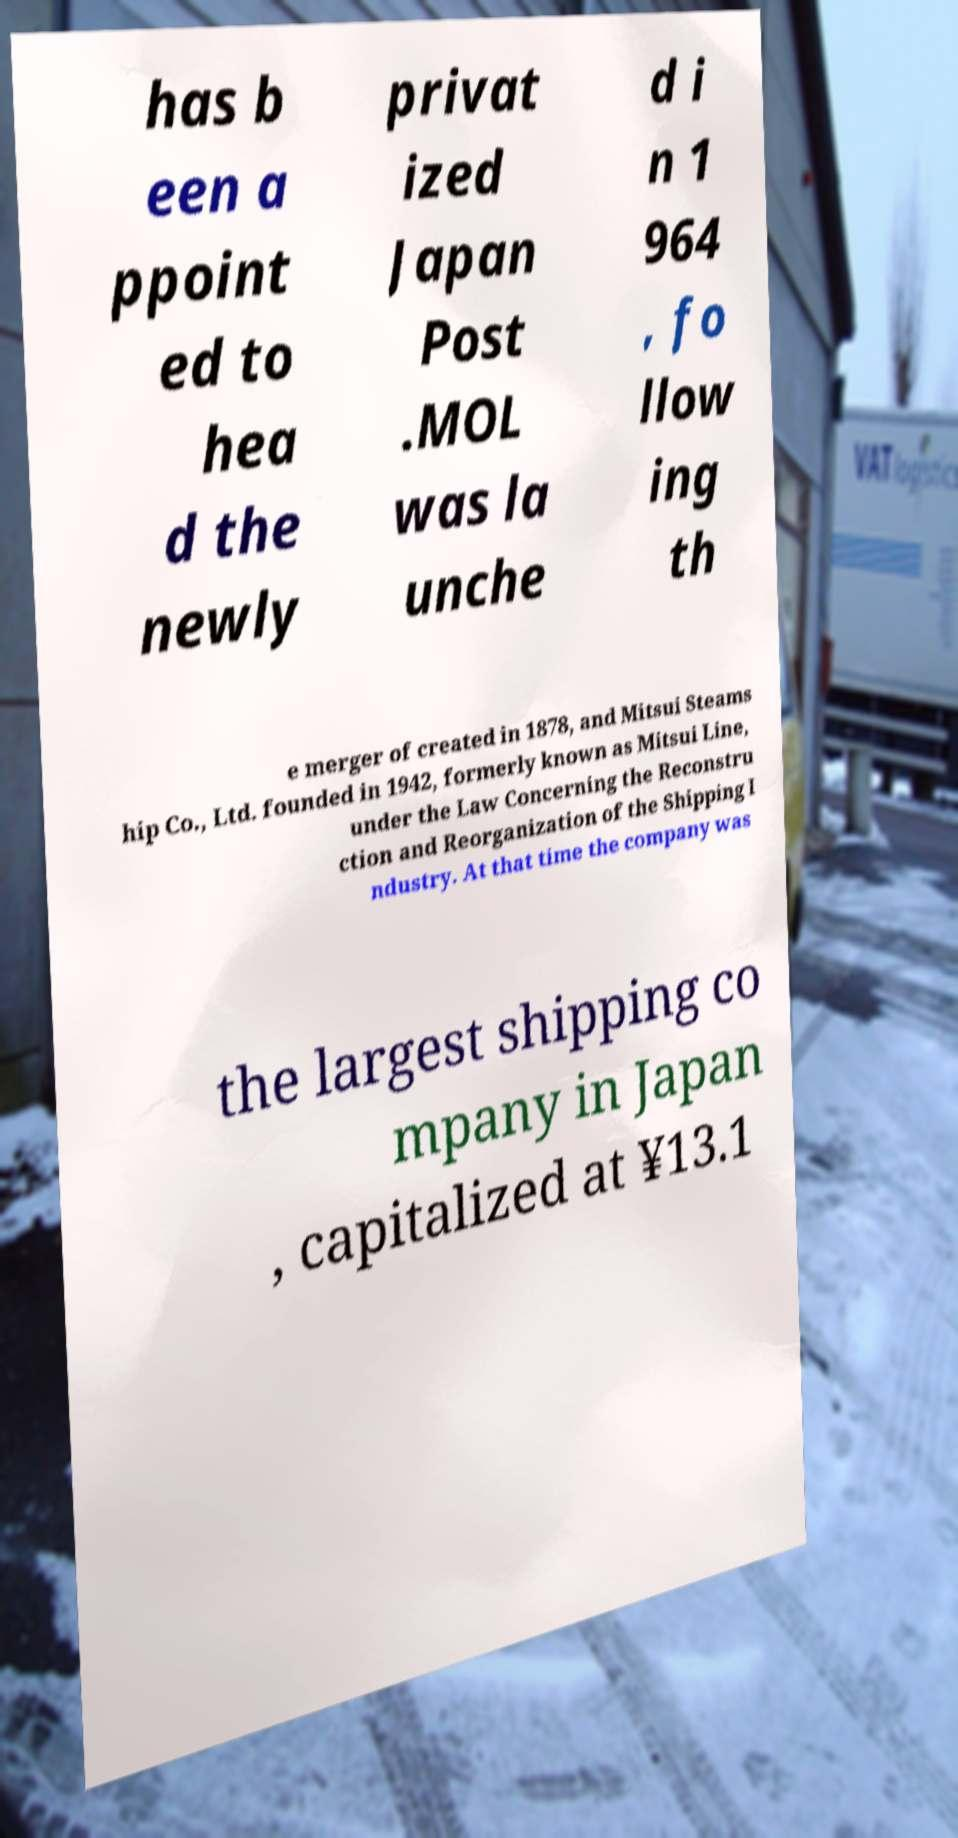Can you accurately transcribe the text from the provided image for me? has b een a ppoint ed to hea d the newly privat ized Japan Post .MOL was la unche d i n 1 964 , fo llow ing th e merger of created in 1878, and Mitsui Steams hip Co., Ltd. founded in 1942, formerly known as Mitsui Line, under the Law Concerning the Reconstru ction and Reorganization of the Shipping I ndustry. At that time the company was the largest shipping co mpany in Japan , capitalized at ¥13.1 